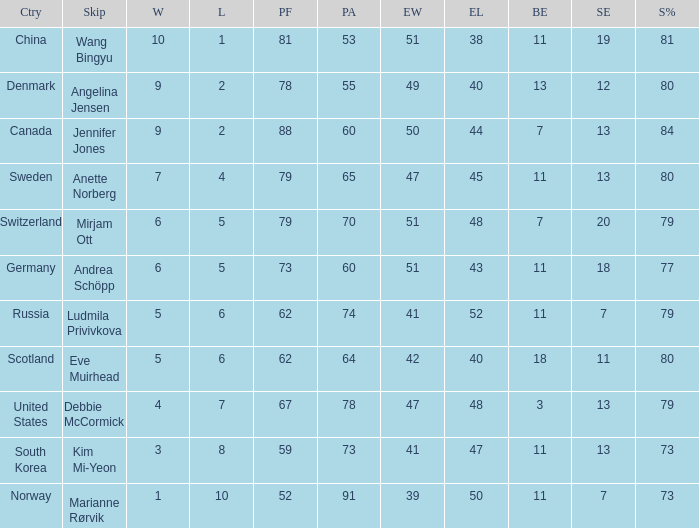When the country was Scotland, how many ends were won? 1.0. 